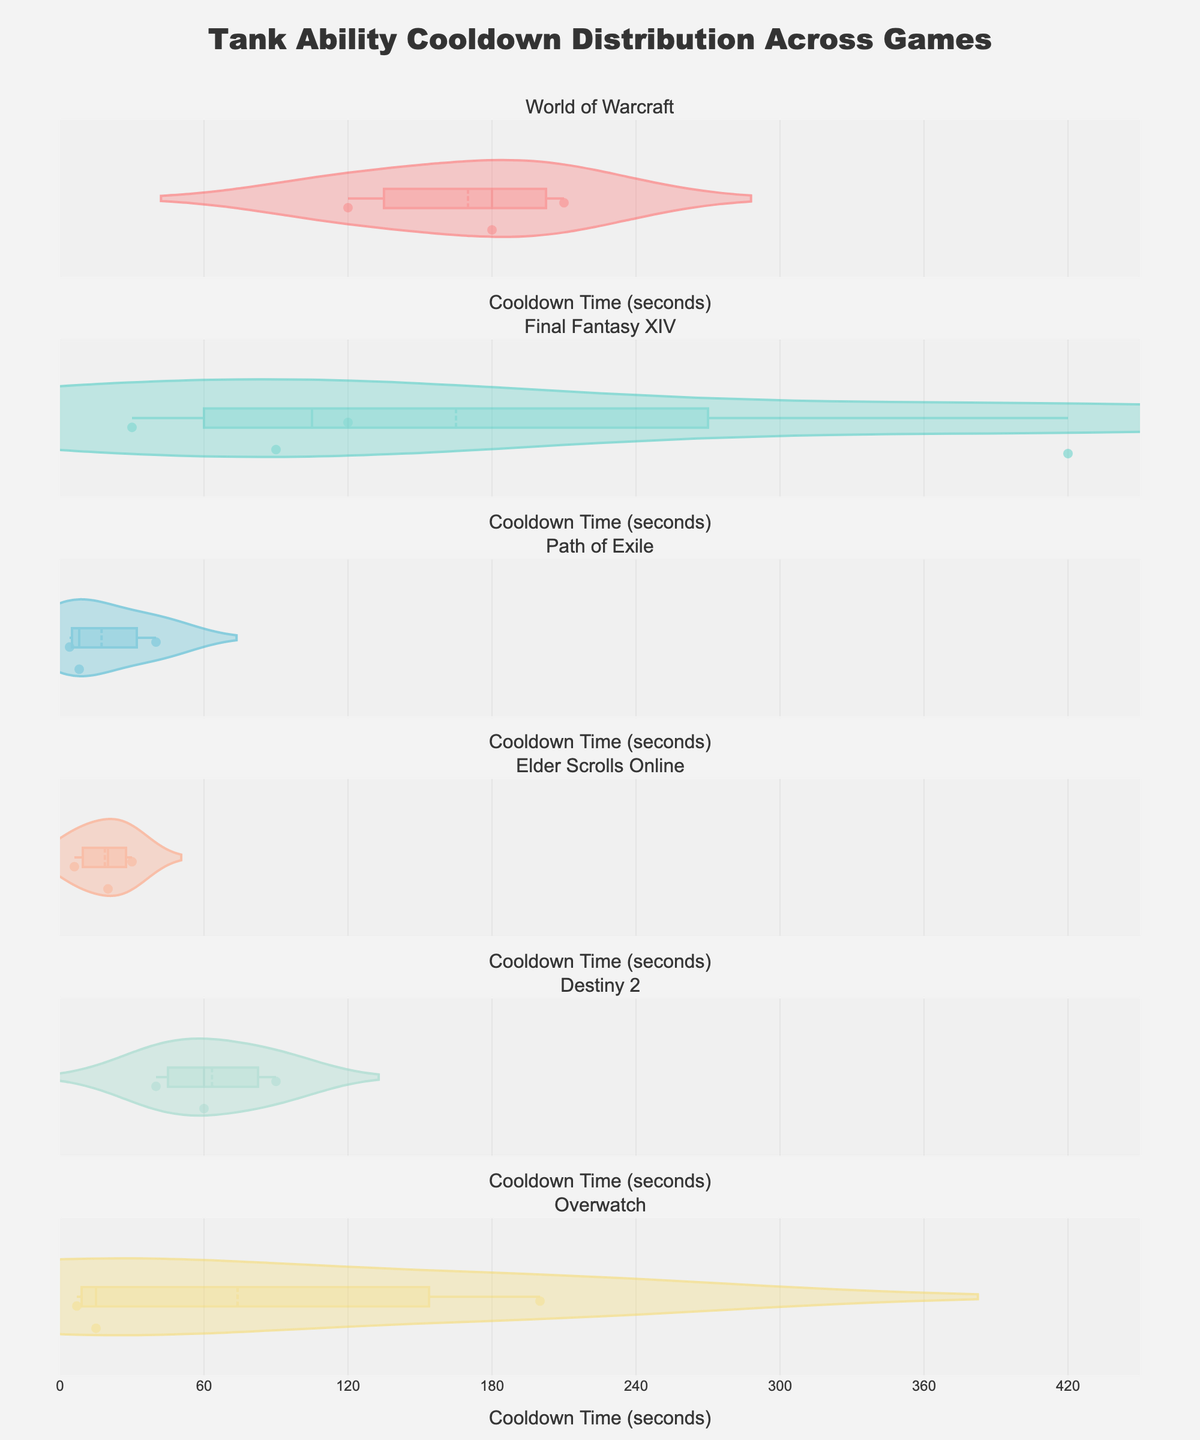What is the cooldown time range for the abilities in World of Warcraft? The cooldown times for World of Warcraft abilities are displayed on the x-axis in the corresponding violin plot. The range spans from the minimum (120 seconds) to the maximum (210 seconds).
Answer: 120 to 210 seconds Which game has the ability with the highest cooldown time? By examining the highest points in each violin plot, we can see that Final Fantasy XIV has an ability with a cooldown time of 420 seconds, which is the highest among all games.
Answer: Final Fantasy XIV What is the median cooldown time for abilities in Path of Exile? The median is represented by the dashed line in each violin plot. In Path of Exile, the median cooldown time is around 8 seconds.
Answer: 8 seconds How many unique abilities from Destiny 2 are shown in the plot? We can count the individual points within the Destiny 2 violin plot. There are three abilities represented by the individual points on the plot.
Answer: 3 abilities Which game has the most evenly distributed cooldown times? The violin plots for World of Warcraft, Final Fantasy XIV, and Path of Exile display different distributions. The one with the most evenly spread distribution would be Final Fantasy XIV, which shows a diverse range of cooldown times without any sharp peaks.
Answer: Final Fantasy XIV Which game features the ability with the shortest cooldown time? Looking at the leftmost points of each violin plot, we can see that Path of Exile has the shortest cooldown time with an ability at 4 seconds.
Answer: Path of Exile Compare the average cooldown times between Overwatch and Elder Scrolls Online. Which game has a higher average? By observing the mean lines in the violin plots, Overwatch's mean is around 74 seconds, whereas Elder Scrolls Online's mean is around 18 seconds. So, Overwatch has a higher average cooldown time.
Answer: Overwatch How does the range of cooldown times in Destiny 2 compare to that in Final Fantasy XIV? Destiny 2's cooldown range is approximately from 40 to 90 seconds, while Final Fantasy XIV ranges from 30 to 420 seconds. Thus, Final Fantasy XIV has a significantly broader range.
Answer: Final Fantasy XIV has a broader range Are there any games where the cooldown times of abilities do not exceed 100 seconds? By checking the violin plots, Path of Exile and Elder Scrolls Online show abilities with cooldown times all under 100 seconds.
Answer: Path of Exile and Elder Scrolls Online 